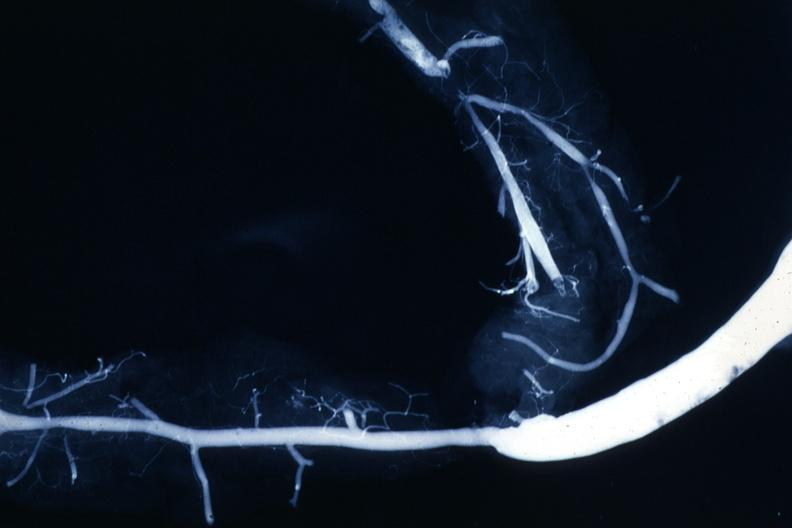what is present?
Answer the question using a single word or phrase. Cardiovascular 